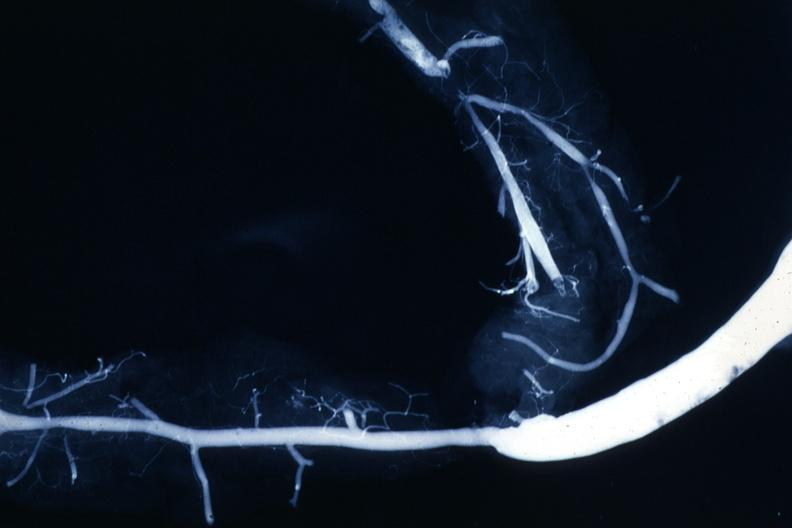what is present?
Answer the question using a single word or phrase. Cardiovascular 